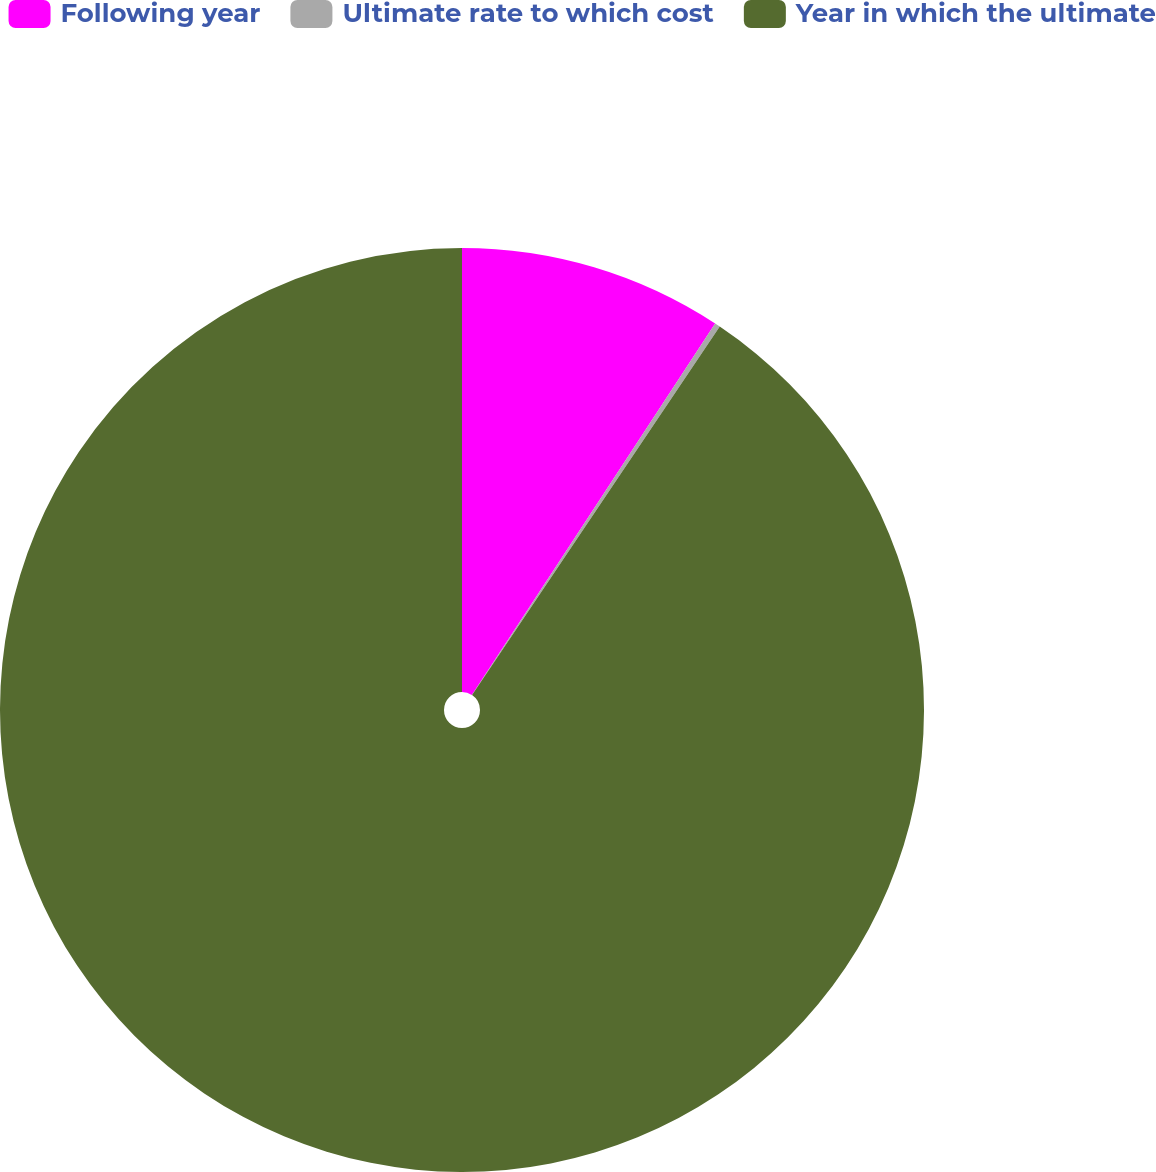<chart> <loc_0><loc_0><loc_500><loc_500><pie_chart><fcel>Following year<fcel>Ultimate rate to which cost<fcel>Year in which the ultimate<nl><fcel>9.23%<fcel>0.19%<fcel>90.58%<nl></chart> 